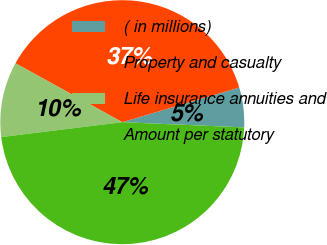<chart> <loc_0><loc_0><loc_500><loc_500><pie_chart><fcel>( in millions)<fcel>Property and casualty<fcel>Life insurance annuities and<fcel>Amount per statutory<nl><fcel>5.27%<fcel>37.4%<fcel>9.97%<fcel>47.37%<nl></chart> 